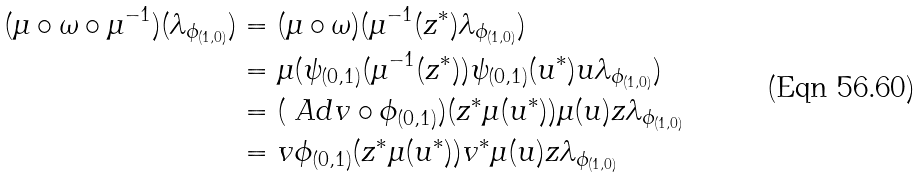<formula> <loc_0><loc_0><loc_500><loc_500>( \mu \circ \omega \circ \mu ^ { - 1 } ) ( \lambda _ { \phi _ { ( 1 , 0 ) } } ) & = ( \mu \circ \omega ) ( \mu ^ { - 1 } ( z ^ { * } ) \lambda _ { \phi _ { ( 1 , 0 ) } } ) \\ & = \mu ( \psi _ { ( 0 , 1 ) } ( \mu ^ { - 1 } ( z ^ { * } ) ) \psi _ { ( 0 , 1 ) } ( u ^ { * } ) u \lambda _ { \phi _ { ( 1 , 0 ) } } ) \\ & = ( \ A d v \circ \phi _ { ( 0 , 1 ) } ) ( z ^ { * } \mu ( u ^ { * } ) ) \mu ( u ) z \lambda _ { \phi _ { ( 1 , 0 ) } } \\ & = v \phi _ { ( 0 , 1 ) } ( z ^ { * } \mu ( u ^ { * } ) ) v ^ { * } \mu ( u ) z \lambda _ { \phi _ { ( 1 , 0 ) } }</formula> 